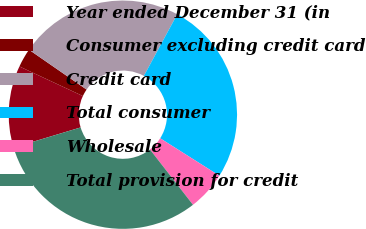Convert chart to OTSL. <chart><loc_0><loc_0><loc_500><loc_500><pie_chart><fcel>Year ended December 31 (in<fcel>Consumer excluding credit card<fcel>Credit card<fcel>Total consumer<fcel>Wholesale<fcel>Total provision for credit<nl><fcel>11.6%<fcel>2.69%<fcel>23.26%<fcel>26.08%<fcel>5.5%<fcel>30.86%<nl></chart> 